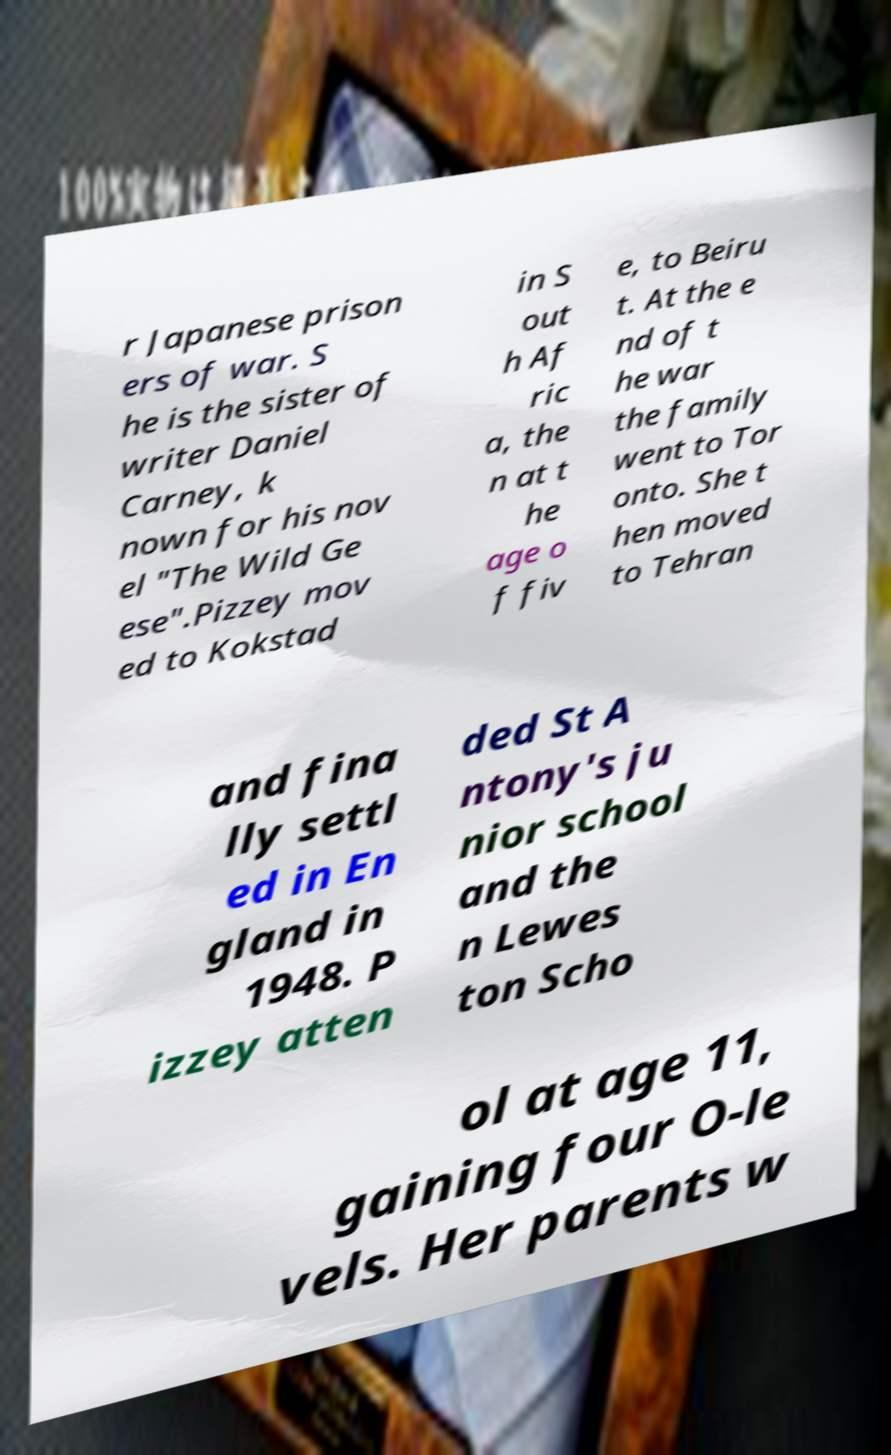There's text embedded in this image that I need extracted. Can you transcribe it verbatim? r Japanese prison ers of war. S he is the sister of writer Daniel Carney, k nown for his nov el "The Wild Ge ese".Pizzey mov ed to Kokstad in S out h Af ric a, the n at t he age o f fiv e, to Beiru t. At the e nd of t he war the family went to Tor onto. She t hen moved to Tehran and fina lly settl ed in En gland in 1948. P izzey atten ded St A ntony's ju nior school and the n Lewes ton Scho ol at age 11, gaining four O-le vels. Her parents w 